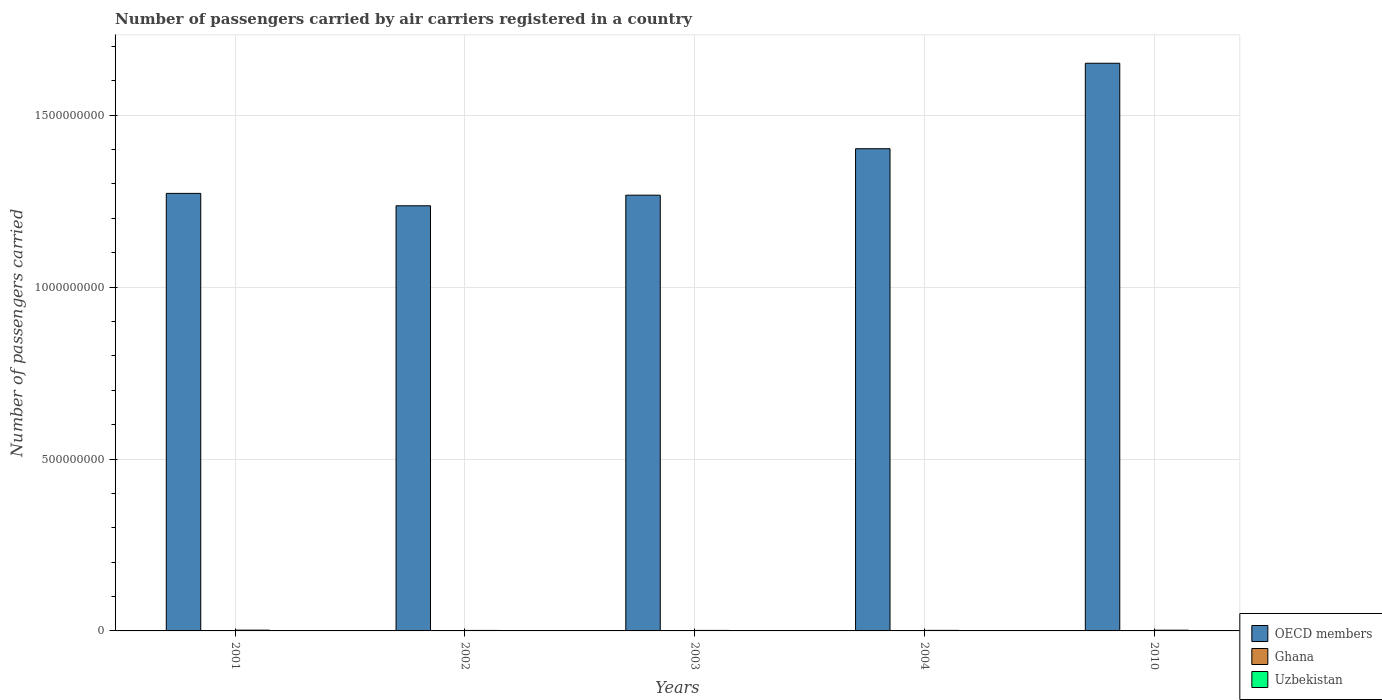How many groups of bars are there?
Your response must be concise. 5. Are the number of bars per tick equal to the number of legend labels?
Your answer should be compact. Yes. Are the number of bars on each tick of the X-axis equal?
Keep it short and to the point. Yes. In how many cases, is the number of bars for a given year not equal to the number of legend labels?
Give a very brief answer. 0. What is the number of passengers carried by air carriers in Ghana in 2002?
Your response must be concise. 2.56e+05. Across all years, what is the maximum number of passengers carried by air carriers in OECD members?
Provide a short and direct response. 1.65e+09. Across all years, what is the minimum number of passengers carried by air carriers in Ghana?
Your answer should be very brief. 9.64e+04. What is the total number of passengers carried by air carriers in OECD members in the graph?
Your answer should be very brief. 6.83e+09. What is the difference between the number of passengers carried by air carriers in Ghana in 2003 and that in 2004?
Make the answer very short. 1.45e+05. What is the difference between the number of passengers carried by air carriers in OECD members in 2003 and the number of passengers carried by air carriers in Uzbekistan in 2002?
Give a very brief answer. 1.27e+09. What is the average number of passengers carried by air carriers in OECD members per year?
Offer a terse response. 1.37e+09. In the year 2004, what is the difference between the number of passengers carried by air carriers in OECD members and number of passengers carried by air carriers in Ghana?
Your answer should be compact. 1.40e+09. In how many years, is the number of passengers carried by air carriers in OECD members greater than 500000000?
Your answer should be very brief. 5. What is the ratio of the number of passengers carried by air carriers in Ghana in 2002 to that in 2010?
Keep it short and to the point. 1.51. Is the number of passengers carried by air carriers in Uzbekistan in 2002 less than that in 2010?
Your answer should be very brief. Yes. What is the difference between the highest and the second highest number of passengers carried by air carriers in Ghana?
Ensure brevity in your answer.  4.55e+04. What is the difference between the highest and the lowest number of passengers carried by air carriers in OECD members?
Keep it short and to the point. 4.15e+08. Is the sum of the number of passengers carried by air carriers in Uzbekistan in 2001 and 2010 greater than the maximum number of passengers carried by air carriers in Ghana across all years?
Offer a very short reply. Yes. What does the 3rd bar from the left in 2002 represents?
Provide a succinct answer. Uzbekistan. What does the 2nd bar from the right in 2002 represents?
Ensure brevity in your answer.  Ghana. How many bars are there?
Give a very brief answer. 15. Where does the legend appear in the graph?
Make the answer very short. Bottom right. What is the title of the graph?
Your response must be concise. Number of passengers carried by air carriers registered in a country. What is the label or title of the X-axis?
Keep it short and to the point. Years. What is the label or title of the Y-axis?
Offer a very short reply. Number of passengers carried. What is the Number of passengers carried of OECD members in 2001?
Make the answer very short. 1.27e+09. What is the Number of passengers carried of Ghana in 2001?
Provide a short and direct response. 3.01e+05. What is the Number of passengers carried in Uzbekistan in 2001?
Your answer should be compact. 2.26e+06. What is the Number of passengers carried of OECD members in 2002?
Your answer should be compact. 1.24e+09. What is the Number of passengers carried in Ghana in 2002?
Ensure brevity in your answer.  2.56e+05. What is the Number of passengers carried of Uzbekistan in 2002?
Your response must be concise. 1.45e+06. What is the Number of passengers carried of OECD members in 2003?
Your answer should be compact. 1.27e+09. What is the Number of passengers carried in Ghana in 2003?
Ensure brevity in your answer.  2.41e+05. What is the Number of passengers carried in Uzbekistan in 2003?
Provide a short and direct response. 1.47e+06. What is the Number of passengers carried in OECD members in 2004?
Your response must be concise. 1.40e+09. What is the Number of passengers carried in Ghana in 2004?
Give a very brief answer. 9.64e+04. What is the Number of passengers carried of Uzbekistan in 2004?
Offer a terse response. 1.59e+06. What is the Number of passengers carried of OECD members in 2010?
Give a very brief answer. 1.65e+09. What is the Number of passengers carried of Ghana in 2010?
Give a very brief answer. 1.69e+05. What is the Number of passengers carried in Uzbekistan in 2010?
Provide a succinct answer. 2.11e+06. Across all years, what is the maximum Number of passengers carried of OECD members?
Make the answer very short. 1.65e+09. Across all years, what is the maximum Number of passengers carried of Ghana?
Offer a very short reply. 3.01e+05. Across all years, what is the maximum Number of passengers carried in Uzbekistan?
Ensure brevity in your answer.  2.26e+06. Across all years, what is the minimum Number of passengers carried in OECD members?
Provide a succinct answer. 1.24e+09. Across all years, what is the minimum Number of passengers carried of Ghana?
Keep it short and to the point. 9.64e+04. Across all years, what is the minimum Number of passengers carried of Uzbekistan?
Ensure brevity in your answer.  1.45e+06. What is the total Number of passengers carried in OECD members in the graph?
Ensure brevity in your answer.  6.83e+09. What is the total Number of passengers carried of Ghana in the graph?
Ensure brevity in your answer.  1.06e+06. What is the total Number of passengers carried in Uzbekistan in the graph?
Offer a very short reply. 8.88e+06. What is the difference between the Number of passengers carried of OECD members in 2001 and that in 2002?
Provide a succinct answer. 3.61e+07. What is the difference between the Number of passengers carried of Ghana in 2001 and that in 2002?
Provide a short and direct response. 4.55e+04. What is the difference between the Number of passengers carried of Uzbekistan in 2001 and that in 2002?
Your response must be concise. 8.05e+05. What is the difference between the Number of passengers carried of OECD members in 2001 and that in 2003?
Provide a succinct answer. 5.24e+06. What is the difference between the Number of passengers carried of Ghana in 2001 and that in 2003?
Ensure brevity in your answer.  6.00e+04. What is the difference between the Number of passengers carried of Uzbekistan in 2001 and that in 2003?
Offer a terse response. 7.91e+05. What is the difference between the Number of passengers carried in OECD members in 2001 and that in 2004?
Offer a terse response. -1.30e+08. What is the difference between the Number of passengers carried of Ghana in 2001 and that in 2004?
Provide a short and direct response. 2.05e+05. What is the difference between the Number of passengers carried of Uzbekistan in 2001 and that in 2004?
Give a very brief answer. 6.68e+05. What is the difference between the Number of passengers carried in OECD members in 2001 and that in 2010?
Your answer should be compact. -3.78e+08. What is the difference between the Number of passengers carried in Ghana in 2001 and that in 2010?
Provide a short and direct response. 1.32e+05. What is the difference between the Number of passengers carried of Uzbekistan in 2001 and that in 2010?
Provide a succinct answer. 1.42e+05. What is the difference between the Number of passengers carried of OECD members in 2002 and that in 2003?
Give a very brief answer. -3.09e+07. What is the difference between the Number of passengers carried of Ghana in 2002 and that in 2003?
Ensure brevity in your answer.  1.45e+04. What is the difference between the Number of passengers carried of Uzbekistan in 2002 and that in 2003?
Keep it short and to the point. -1.48e+04. What is the difference between the Number of passengers carried in OECD members in 2002 and that in 2004?
Make the answer very short. -1.66e+08. What is the difference between the Number of passengers carried of Ghana in 2002 and that in 2004?
Provide a succinct answer. 1.59e+05. What is the difference between the Number of passengers carried in Uzbekistan in 2002 and that in 2004?
Your answer should be very brief. -1.37e+05. What is the difference between the Number of passengers carried of OECD members in 2002 and that in 2010?
Your answer should be very brief. -4.15e+08. What is the difference between the Number of passengers carried of Ghana in 2002 and that in 2010?
Make the answer very short. 8.66e+04. What is the difference between the Number of passengers carried of Uzbekistan in 2002 and that in 2010?
Ensure brevity in your answer.  -6.63e+05. What is the difference between the Number of passengers carried of OECD members in 2003 and that in 2004?
Offer a terse response. -1.35e+08. What is the difference between the Number of passengers carried of Ghana in 2003 and that in 2004?
Make the answer very short. 1.45e+05. What is the difference between the Number of passengers carried of Uzbekistan in 2003 and that in 2004?
Offer a very short reply. -1.22e+05. What is the difference between the Number of passengers carried in OECD members in 2003 and that in 2010?
Provide a succinct answer. -3.84e+08. What is the difference between the Number of passengers carried of Ghana in 2003 and that in 2010?
Your answer should be very brief. 7.21e+04. What is the difference between the Number of passengers carried in Uzbekistan in 2003 and that in 2010?
Provide a succinct answer. -6.48e+05. What is the difference between the Number of passengers carried in OECD members in 2004 and that in 2010?
Provide a succinct answer. -2.49e+08. What is the difference between the Number of passengers carried in Ghana in 2004 and that in 2010?
Ensure brevity in your answer.  -7.26e+04. What is the difference between the Number of passengers carried in Uzbekistan in 2004 and that in 2010?
Make the answer very short. -5.26e+05. What is the difference between the Number of passengers carried of OECD members in 2001 and the Number of passengers carried of Ghana in 2002?
Your answer should be very brief. 1.27e+09. What is the difference between the Number of passengers carried in OECD members in 2001 and the Number of passengers carried in Uzbekistan in 2002?
Your answer should be compact. 1.27e+09. What is the difference between the Number of passengers carried in Ghana in 2001 and the Number of passengers carried in Uzbekistan in 2002?
Offer a very short reply. -1.15e+06. What is the difference between the Number of passengers carried of OECD members in 2001 and the Number of passengers carried of Ghana in 2003?
Offer a very short reply. 1.27e+09. What is the difference between the Number of passengers carried of OECD members in 2001 and the Number of passengers carried of Uzbekistan in 2003?
Provide a short and direct response. 1.27e+09. What is the difference between the Number of passengers carried in Ghana in 2001 and the Number of passengers carried in Uzbekistan in 2003?
Make the answer very short. -1.16e+06. What is the difference between the Number of passengers carried in OECD members in 2001 and the Number of passengers carried in Ghana in 2004?
Your answer should be compact. 1.27e+09. What is the difference between the Number of passengers carried in OECD members in 2001 and the Number of passengers carried in Uzbekistan in 2004?
Keep it short and to the point. 1.27e+09. What is the difference between the Number of passengers carried in Ghana in 2001 and the Number of passengers carried in Uzbekistan in 2004?
Keep it short and to the point. -1.29e+06. What is the difference between the Number of passengers carried of OECD members in 2001 and the Number of passengers carried of Ghana in 2010?
Provide a succinct answer. 1.27e+09. What is the difference between the Number of passengers carried of OECD members in 2001 and the Number of passengers carried of Uzbekistan in 2010?
Your response must be concise. 1.27e+09. What is the difference between the Number of passengers carried of Ghana in 2001 and the Number of passengers carried of Uzbekistan in 2010?
Ensure brevity in your answer.  -1.81e+06. What is the difference between the Number of passengers carried in OECD members in 2002 and the Number of passengers carried in Ghana in 2003?
Ensure brevity in your answer.  1.24e+09. What is the difference between the Number of passengers carried of OECD members in 2002 and the Number of passengers carried of Uzbekistan in 2003?
Make the answer very short. 1.24e+09. What is the difference between the Number of passengers carried in Ghana in 2002 and the Number of passengers carried in Uzbekistan in 2003?
Keep it short and to the point. -1.21e+06. What is the difference between the Number of passengers carried of OECD members in 2002 and the Number of passengers carried of Ghana in 2004?
Ensure brevity in your answer.  1.24e+09. What is the difference between the Number of passengers carried of OECD members in 2002 and the Number of passengers carried of Uzbekistan in 2004?
Your response must be concise. 1.24e+09. What is the difference between the Number of passengers carried of Ghana in 2002 and the Number of passengers carried of Uzbekistan in 2004?
Offer a very short reply. -1.33e+06. What is the difference between the Number of passengers carried in OECD members in 2002 and the Number of passengers carried in Ghana in 2010?
Make the answer very short. 1.24e+09. What is the difference between the Number of passengers carried in OECD members in 2002 and the Number of passengers carried in Uzbekistan in 2010?
Offer a very short reply. 1.23e+09. What is the difference between the Number of passengers carried in Ghana in 2002 and the Number of passengers carried in Uzbekistan in 2010?
Make the answer very short. -1.86e+06. What is the difference between the Number of passengers carried of OECD members in 2003 and the Number of passengers carried of Ghana in 2004?
Your response must be concise. 1.27e+09. What is the difference between the Number of passengers carried in OECD members in 2003 and the Number of passengers carried in Uzbekistan in 2004?
Make the answer very short. 1.27e+09. What is the difference between the Number of passengers carried of Ghana in 2003 and the Number of passengers carried of Uzbekistan in 2004?
Give a very brief answer. -1.35e+06. What is the difference between the Number of passengers carried in OECD members in 2003 and the Number of passengers carried in Ghana in 2010?
Your answer should be compact. 1.27e+09. What is the difference between the Number of passengers carried of OECD members in 2003 and the Number of passengers carried of Uzbekistan in 2010?
Keep it short and to the point. 1.27e+09. What is the difference between the Number of passengers carried of Ghana in 2003 and the Number of passengers carried of Uzbekistan in 2010?
Provide a short and direct response. -1.87e+06. What is the difference between the Number of passengers carried in OECD members in 2004 and the Number of passengers carried in Ghana in 2010?
Your answer should be compact. 1.40e+09. What is the difference between the Number of passengers carried of OECD members in 2004 and the Number of passengers carried of Uzbekistan in 2010?
Offer a very short reply. 1.40e+09. What is the difference between the Number of passengers carried of Ghana in 2004 and the Number of passengers carried of Uzbekistan in 2010?
Your answer should be very brief. -2.02e+06. What is the average Number of passengers carried in OECD members per year?
Offer a very short reply. 1.37e+09. What is the average Number of passengers carried of Ghana per year?
Your answer should be compact. 2.13e+05. What is the average Number of passengers carried of Uzbekistan per year?
Ensure brevity in your answer.  1.78e+06. In the year 2001, what is the difference between the Number of passengers carried of OECD members and Number of passengers carried of Ghana?
Your answer should be compact. 1.27e+09. In the year 2001, what is the difference between the Number of passengers carried in OECD members and Number of passengers carried in Uzbekistan?
Offer a terse response. 1.27e+09. In the year 2001, what is the difference between the Number of passengers carried of Ghana and Number of passengers carried of Uzbekistan?
Offer a very short reply. -1.96e+06. In the year 2002, what is the difference between the Number of passengers carried of OECD members and Number of passengers carried of Ghana?
Make the answer very short. 1.24e+09. In the year 2002, what is the difference between the Number of passengers carried in OECD members and Number of passengers carried in Uzbekistan?
Provide a short and direct response. 1.24e+09. In the year 2002, what is the difference between the Number of passengers carried of Ghana and Number of passengers carried of Uzbekistan?
Provide a succinct answer. -1.20e+06. In the year 2003, what is the difference between the Number of passengers carried of OECD members and Number of passengers carried of Ghana?
Provide a succinct answer. 1.27e+09. In the year 2003, what is the difference between the Number of passengers carried of OECD members and Number of passengers carried of Uzbekistan?
Your answer should be very brief. 1.27e+09. In the year 2003, what is the difference between the Number of passengers carried in Ghana and Number of passengers carried in Uzbekistan?
Provide a short and direct response. -1.22e+06. In the year 2004, what is the difference between the Number of passengers carried in OECD members and Number of passengers carried in Ghana?
Your answer should be compact. 1.40e+09. In the year 2004, what is the difference between the Number of passengers carried in OECD members and Number of passengers carried in Uzbekistan?
Your answer should be compact. 1.40e+09. In the year 2004, what is the difference between the Number of passengers carried in Ghana and Number of passengers carried in Uzbekistan?
Your answer should be compact. -1.49e+06. In the year 2010, what is the difference between the Number of passengers carried in OECD members and Number of passengers carried in Ghana?
Your response must be concise. 1.65e+09. In the year 2010, what is the difference between the Number of passengers carried in OECD members and Number of passengers carried in Uzbekistan?
Your response must be concise. 1.65e+09. In the year 2010, what is the difference between the Number of passengers carried in Ghana and Number of passengers carried in Uzbekistan?
Your answer should be very brief. -1.95e+06. What is the ratio of the Number of passengers carried of OECD members in 2001 to that in 2002?
Give a very brief answer. 1.03. What is the ratio of the Number of passengers carried in Ghana in 2001 to that in 2002?
Provide a short and direct response. 1.18. What is the ratio of the Number of passengers carried in Uzbekistan in 2001 to that in 2002?
Give a very brief answer. 1.55. What is the ratio of the Number of passengers carried of OECD members in 2001 to that in 2003?
Make the answer very short. 1. What is the ratio of the Number of passengers carried in Ghana in 2001 to that in 2003?
Keep it short and to the point. 1.25. What is the ratio of the Number of passengers carried of Uzbekistan in 2001 to that in 2003?
Provide a succinct answer. 1.54. What is the ratio of the Number of passengers carried in OECD members in 2001 to that in 2004?
Keep it short and to the point. 0.91. What is the ratio of the Number of passengers carried in Ghana in 2001 to that in 2004?
Keep it short and to the point. 3.12. What is the ratio of the Number of passengers carried in Uzbekistan in 2001 to that in 2004?
Your answer should be very brief. 1.42. What is the ratio of the Number of passengers carried of OECD members in 2001 to that in 2010?
Give a very brief answer. 0.77. What is the ratio of the Number of passengers carried in Ghana in 2001 to that in 2010?
Keep it short and to the point. 1.78. What is the ratio of the Number of passengers carried of Uzbekistan in 2001 to that in 2010?
Offer a terse response. 1.07. What is the ratio of the Number of passengers carried in OECD members in 2002 to that in 2003?
Keep it short and to the point. 0.98. What is the ratio of the Number of passengers carried of Ghana in 2002 to that in 2003?
Make the answer very short. 1.06. What is the ratio of the Number of passengers carried in Uzbekistan in 2002 to that in 2003?
Keep it short and to the point. 0.99. What is the ratio of the Number of passengers carried in OECD members in 2002 to that in 2004?
Your answer should be compact. 0.88. What is the ratio of the Number of passengers carried of Ghana in 2002 to that in 2004?
Your answer should be very brief. 2.65. What is the ratio of the Number of passengers carried of Uzbekistan in 2002 to that in 2004?
Provide a succinct answer. 0.91. What is the ratio of the Number of passengers carried of OECD members in 2002 to that in 2010?
Ensure brevity in your answer.  0.75. What is the ratio of the Number of passengers carried in Ghana in 2002 to that in 2010?
Offer a terse response. 1.51. What is the ratio of the Number of passengers carried of Uzbekistan in 2002 to that in 2010?
Your answer should be very brief. 0.69. What is the ratio of the Number of passengers carried of OECD members in 2003 to that in 2004?
Your answer should be very brief. 0.9. What is the ratio of the Number of passengers carried in Ghana in 2003 to that in 2004?
Ensure brevity in your answer.  2.5. What is the ratio of the Number of passengers carried in Uzbekistan in 2003 to that in 2004?
Your answer should be compact. 0.92. What is the ratio of the Number of passengers carried of OECD members in 2003 to that in 2010?
Your response must be concise. 0.77. What is the ratio of the Number of passengers carried in Ghana in 2003 to that in 2010?
Make the answer very short. 1.43. What is the ratio of the Number of passengers carried of Uzbekistan in 2003 to that in 2010?
Provide a succinct answer. 0.69. What is the ratio of the Number of passengers carried in OECD members in 2004 to that in 2010?
Provide a succinct answer. 0.85. What is the ratio of the Number of passengers carried of Ghana in 2004 to that in 2010?
Offer a very short reply. 0.57. What is the ratio of the Number of passengers carried of Uzbekistan in 2004 to that in 2010?
Keep it short and to the point. 0.75. What is the difference between the highest and the second highest Number of passengers carried in OECD members?
Ensure brevity in your answer.  2.49e+08. What is the difference between the highest and the second highest Number of passengers carried of Ghana?
Your response must be concise. 4.55e+04. What is the difference between the highest and the second highest Number of passengers carried of Uzbekistan?
Offer a terse response. 1.42e+05. What is the difference between the highest and the lowest Number of passengers carried in OECD members?
Your answer should be very brief. 4.15e+08. What is the difference between the highest and the lowest Number of passengers carried of Ghana?
Provide a succinct answer. 2.05e+05. What is the difference between the highest and the lowest Number of passengers carried in Uzbekistan?
Keep it short and to the point. 8.05e+05. 